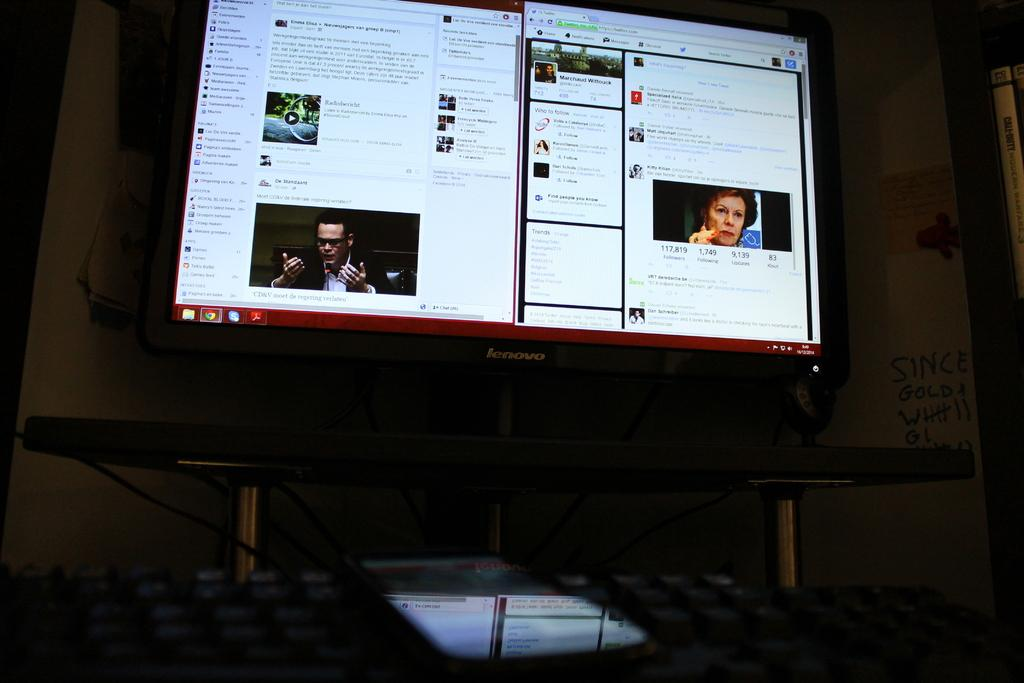<image>
Relay a brief, clear account of the picture shown. a lenovo computer screen that is open to a twitter page 